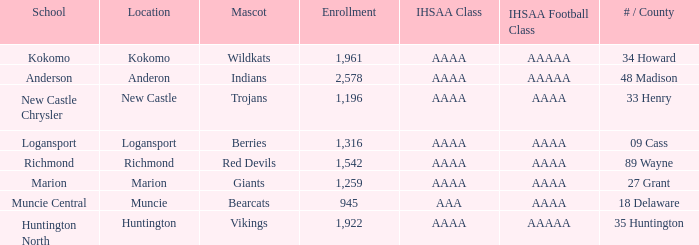What's the IHSAA class of the Red Devils? AAAA. 